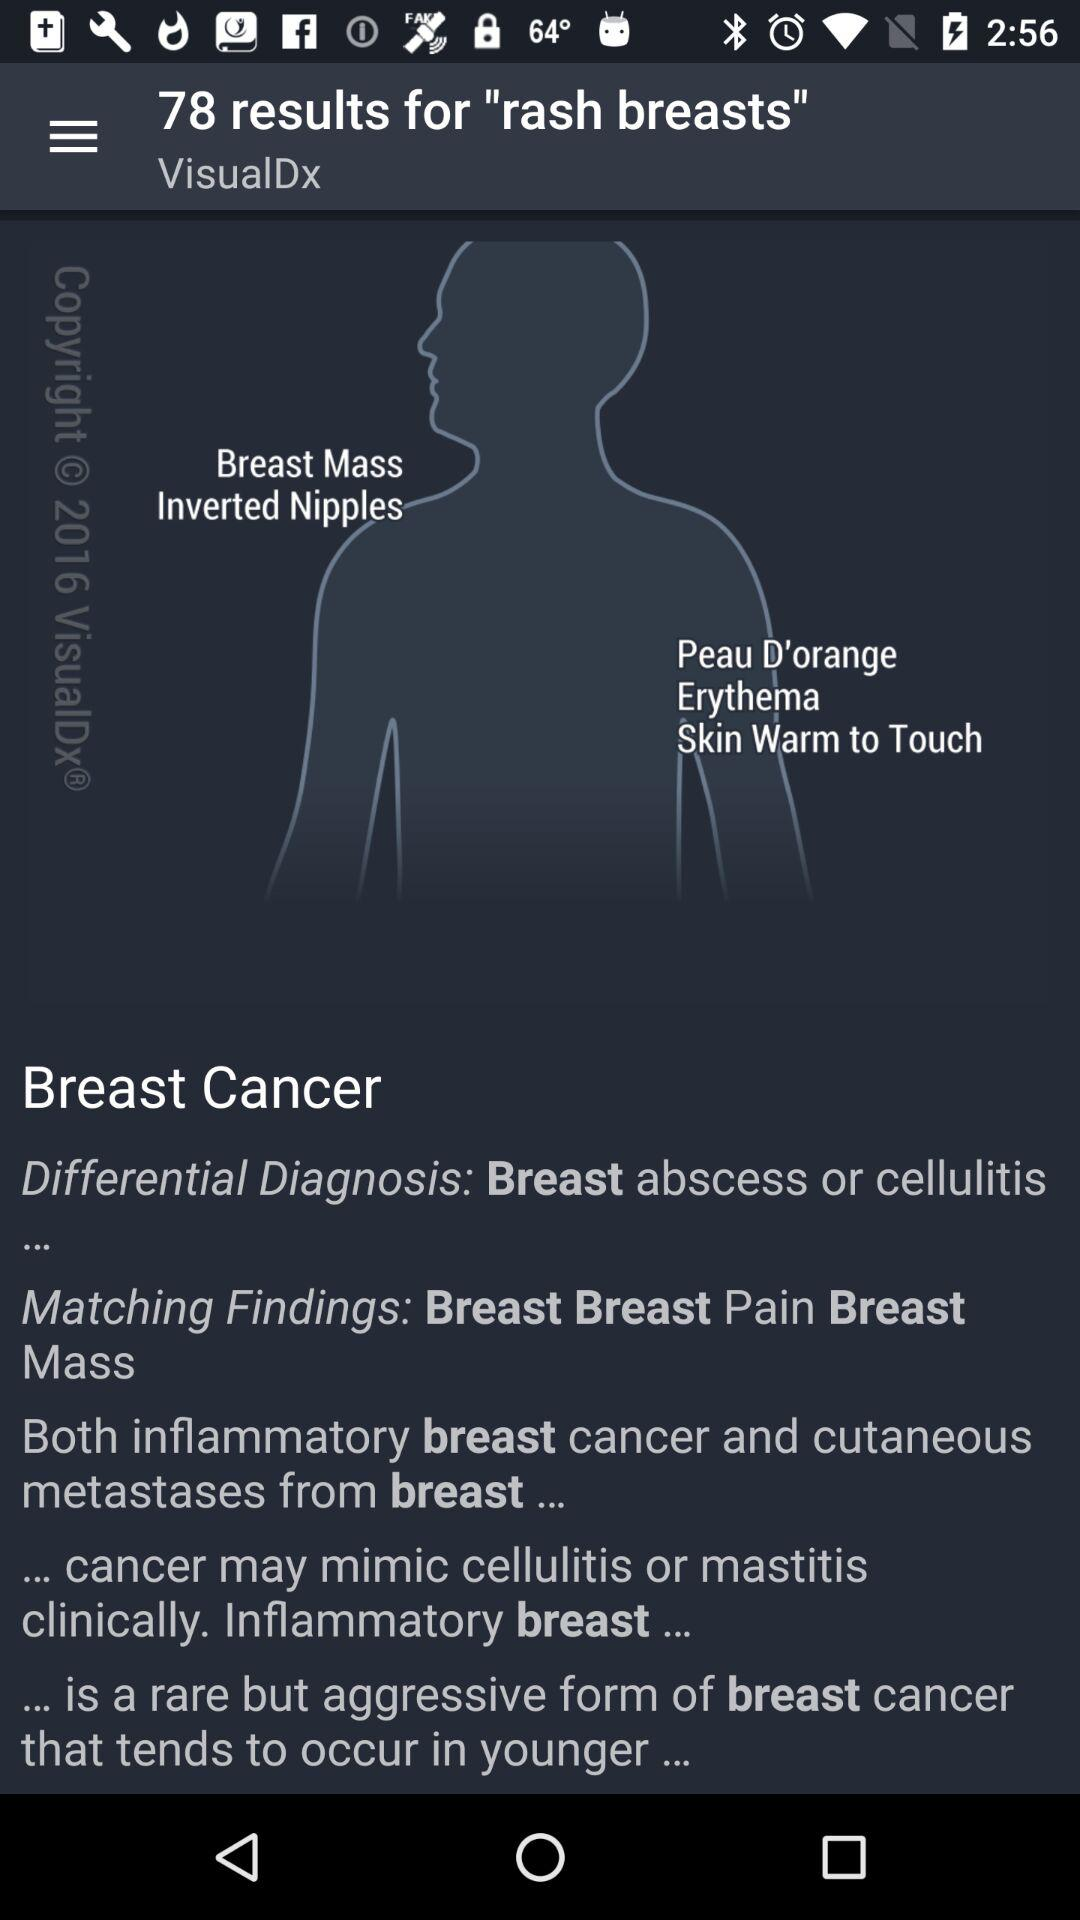How many results are there for "rash breasts"? There are 78 results. 